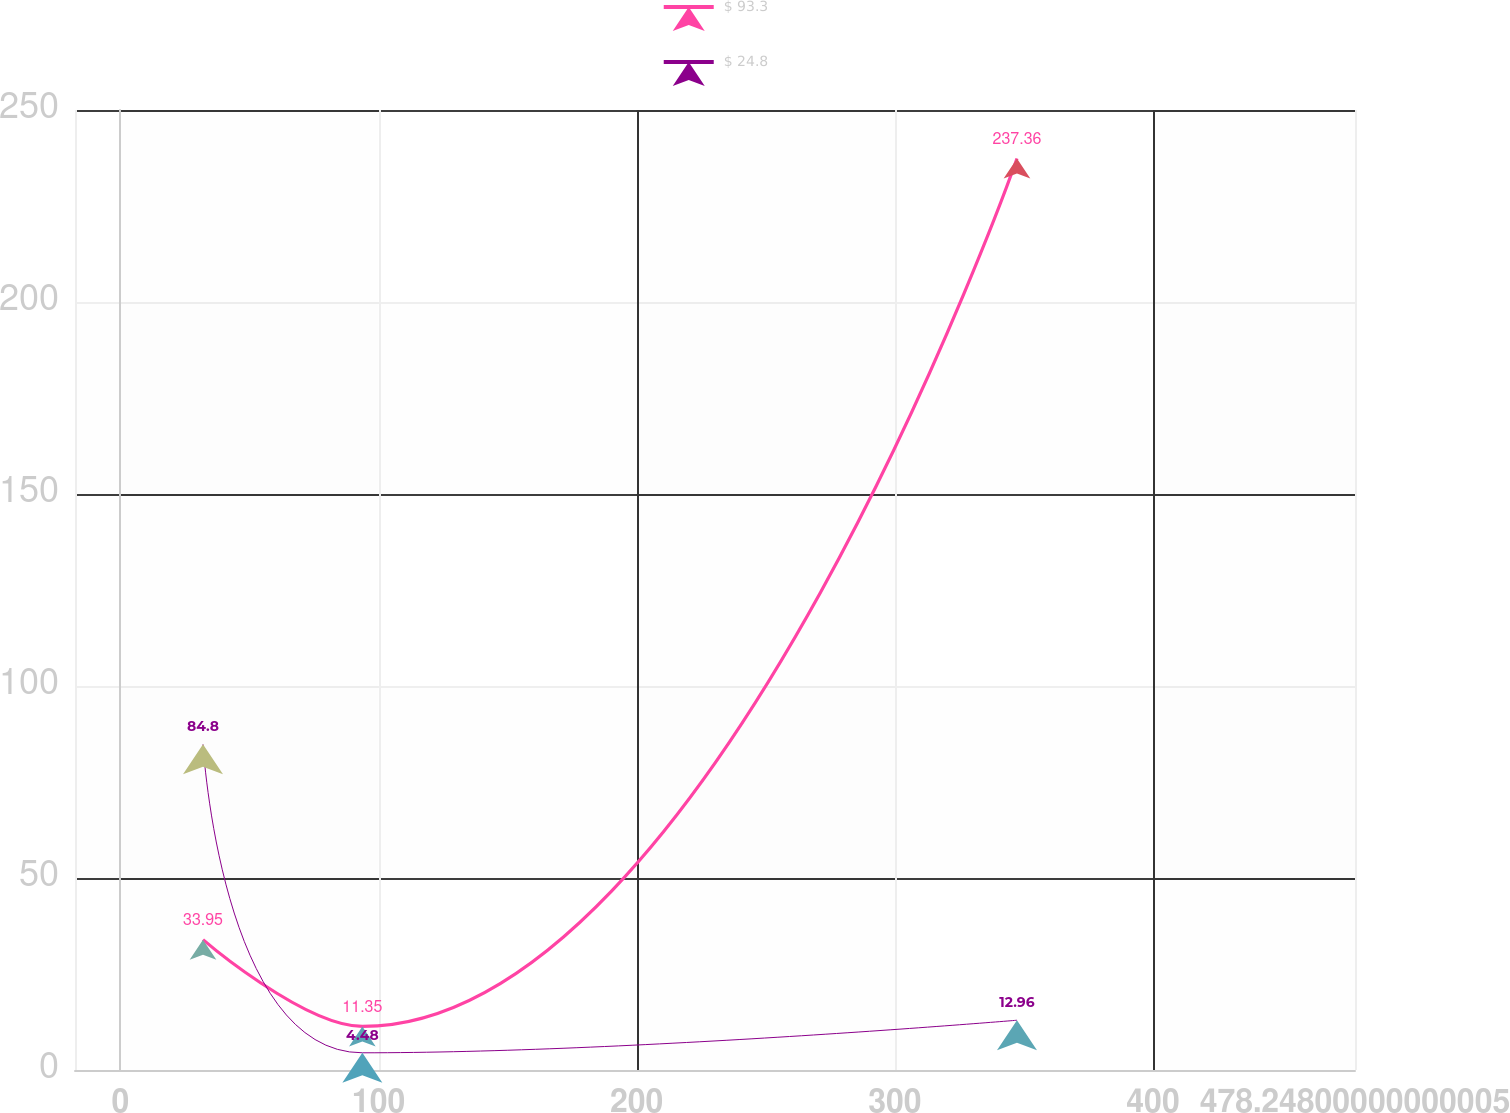Convert chart to OTSL. <chart><loc_0><loc_0><loc_500><loc_500><line_chart><ecel><fcel>$ 93.3<fcel>$ 24.8<nl><fcel>32.01<fcel>33.95<fcel>84.8<nl><fcel>93.74<fcel>11.35<fcel>4.48<nl><fcel>347.31<fcel>237.36<fcel>12.96<nl><fcel>527.83<fcel>108.26<fcel>93.28<nl></chart> 